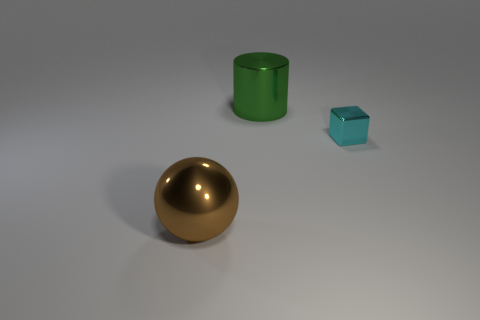Add 2 big purple cubes. How many objects exist? 5 Subtract all blocks. How many objects are left? 2 Subtract all big yellow metallic spheres. Subtract all small cyan metal objects. How many objects are left? 2 Add 2 brown metal things. How many brown metal things are left? 3 Add 3 cyan cylinders. How many cyan cylinders exist? 3 Subtract 0 brown cylinders. How many objects are left? 3 